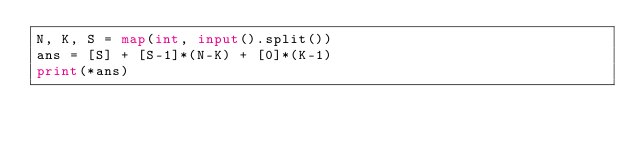<code> <loc_0><loc_0><loc_500><loc_500><_Python_>N, K, S = map(int, input().split())
ans = [S] + [S-1]*(N-K) + [0]*(K-1)
print(*ans)</code> 